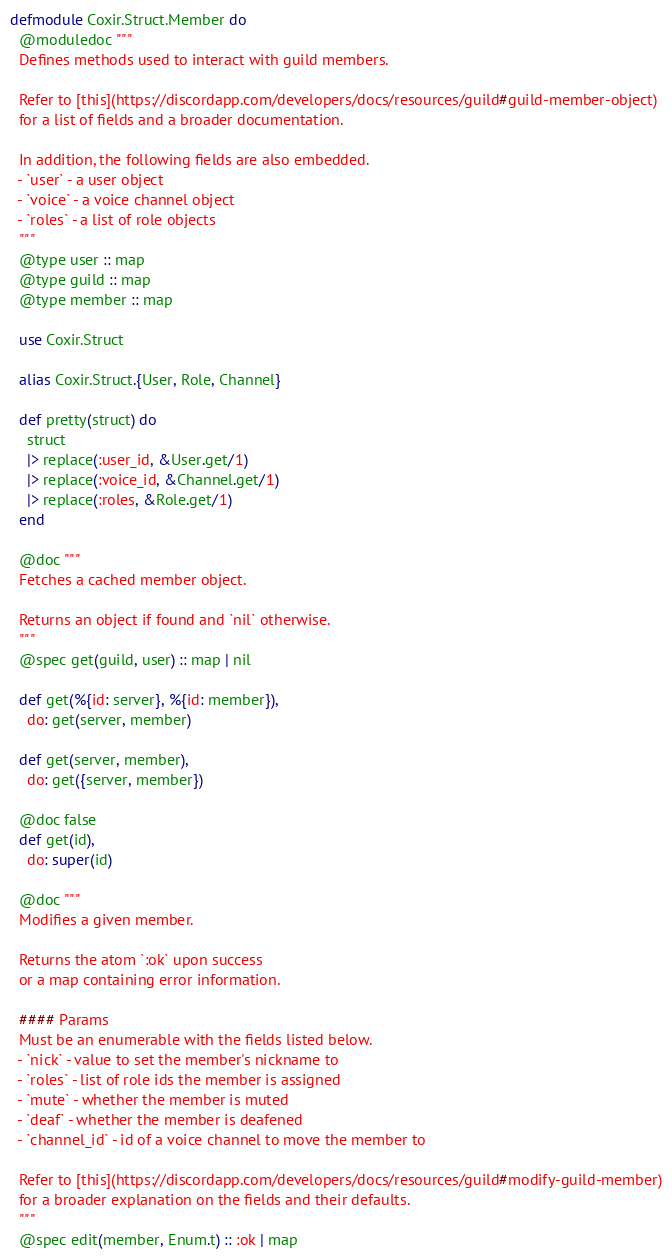Convert code to text. <code><loc_0><loc_0><loc_500><loc_500><_Elixir_>defmodule Coxir.Struct.Member do
  @moduledoc """
  Defines methods used to interact with guild members.

  Refer to [this](https://discordapp.com/developers/docs/resources/guild#guild-member-object)
  for a list of fields and a broader documentation.

  In addition, the following fields are also embedded.
  - `user` - a user object
  - `voice` - a voice channel object
  - `roles` - a list of role objects
  """
  @type user :: map
  @type guild :: map
  @type member :: map

  use Coxir.Struct

  alias Coxir.Struct.{User, Role, Channel}

  def pretty(struct) do
    struct
    |> replace(:user_id, &User.get/1)
    |> replace(:voice_id, &Channel.get/1)
    |> replace(:roles, &Role.get/1)
  end

  @doc """
  Fetches a cached member object.

  Returns an object if found and `nil` otherwise.
  """
  @spec get(guild, user) :: map | nil

  def get(%{id: server}, %{id: member}),
    do: get(server, member)

  def get(server, member),
    do: get({server, member})

  @doc false
  def get(id),
    do: super(id)

  @doc """
  Modifies a given member.

  Returns the atom `:ok` upon success
  or a map containing error information.

  #### Params
  Must be an enumerable with the fields listed below.
  - `nick` - value to set the member's nickname to
  - `roles` - list of role ids the member is assigned
  - `mute` - whether the member is muted
  - `deaf` - whether the member is deafened
  - `channel_id` - id of a voice channel to move the member to

  Refer to [this](https://discordapp.com/developers/docs/resources/guild#modify-guild-member)
  for a broader explanation on the fields and their defaults.
  """
  @spec edit(member, Enum.t) :: :ok | map
</code> 